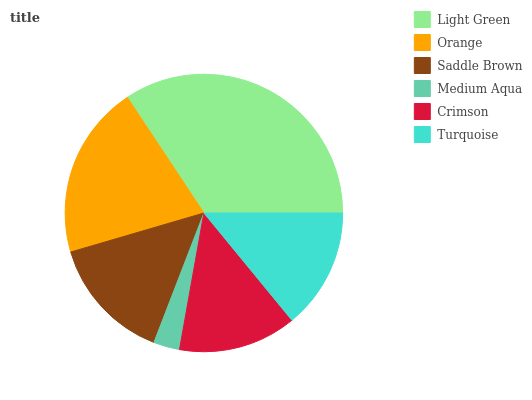Is Medium Aqua the minimum?
Answer yes or no. Yes. Is Light Green the maximum?
Answer yes or no. Yes. Is Orange the minimum?
Answer yes or no. No. Is Orange the maximum?
Answer yes or no. No. Is Light Green greater than Orange?
Answer yes or no. Yes. Is Orange less than Light Green?
Answer yes or no. Yes. Is Orange greater than Light Green?
Answer yes or no. No. Is Light Green less than Orange?
Answer yes or no. No. Is Saddle Brown the high median?
Answer yes or no. Yes. Is Turquoise the low median?
Answer yes or no. Yes. Is Orange the high median?
Answer yes or no. No. Is Saddle Brown the low median?
Answer yes or no. No. 